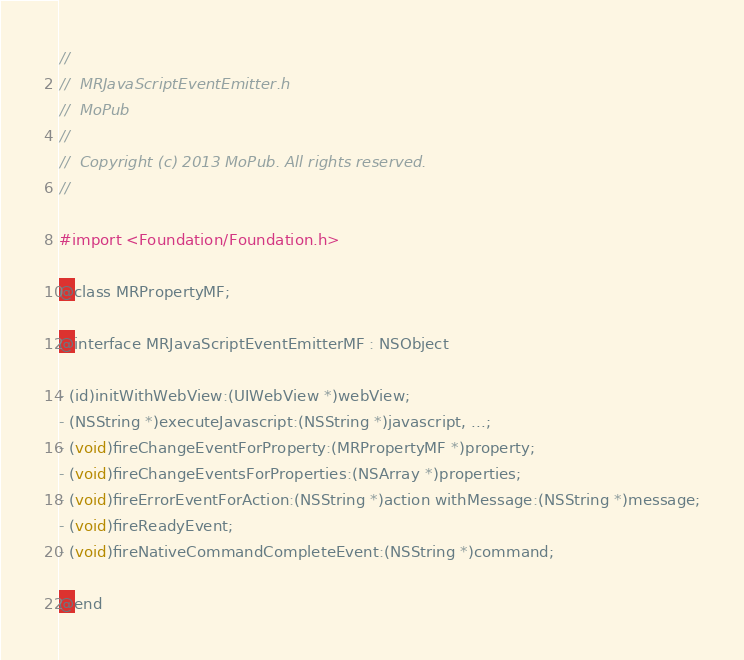<code> <loc_0><loc_0><loc_500><loc_500><_C_>//
//  MRJavaScriptEventEmitter.h
//  MoPub
//
//  Copyright (c) 2013 MoPub. All rights reserved.
//

#import <Foundation/Foundation.h>

@class MRPropertyMF;

@interface MRJavaScriptEventEmitterMF : NSObject

- (id)initWithWebView:(UIWebView *)webView;
- (NSString *)executeJavascript:(NSString *)javascript, ...;
- (void)fireChangeEventForProperty:(MRPropertyMF *)property;
- (void)fireChangeEventsForProperties:(NSArray *)properties;
- (void)fireErrorEventForAction:(NSString *)action withMessage:(NSString *)message;
- (void)fireReadyEvent;
- (void)fireNativeCommandCompleteEvent:(NSString *)command;

@end
</code> 